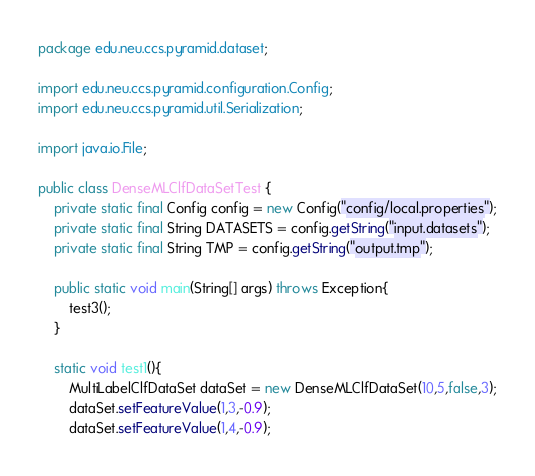<code> <loc_0><loc_0><loc_500><loc_500><_Java_>package edu.neu.ccs.pyramid.dataset;

import edu.neu.ccs.pyramid.configuration.Config;
import edu.neu.ccs.pyramid.util.Serialization;

import java.io.File;

public class DenseMLClfDataSetTest {
    private static final Config config = new Config("config/local.properties");
    private static final String DATASETS = config.getString("input.datasets");
    private static final String TMP = config.getString("output.tmp");

    public static void main(String[] args) throws Exception{
        test3();
    }

    static void test1(){
        MultiLabelClfDataSet dataSet = new DenseMLClfDataSet(10,5,false,3);
        dataSet.setFeatureValue(1,3,-0.9);
        dataSet.setFeatureValue(1,4,-0.9);</code> 